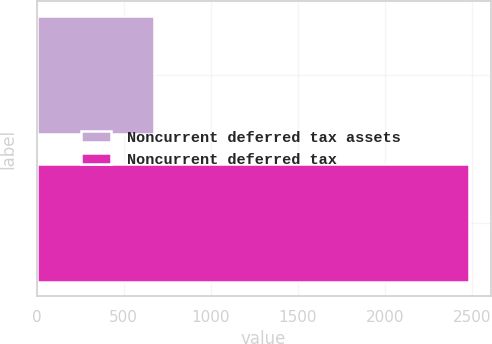Convert chart to OTSL. <chart><loc_0><loc_0><loc_500><loc_500><bar_chart><fcel>Noncurrent deferred tax assets<fcel>Noncurrent deferred tax<nl><fcel>675<fcel>2485<nl></chart> 